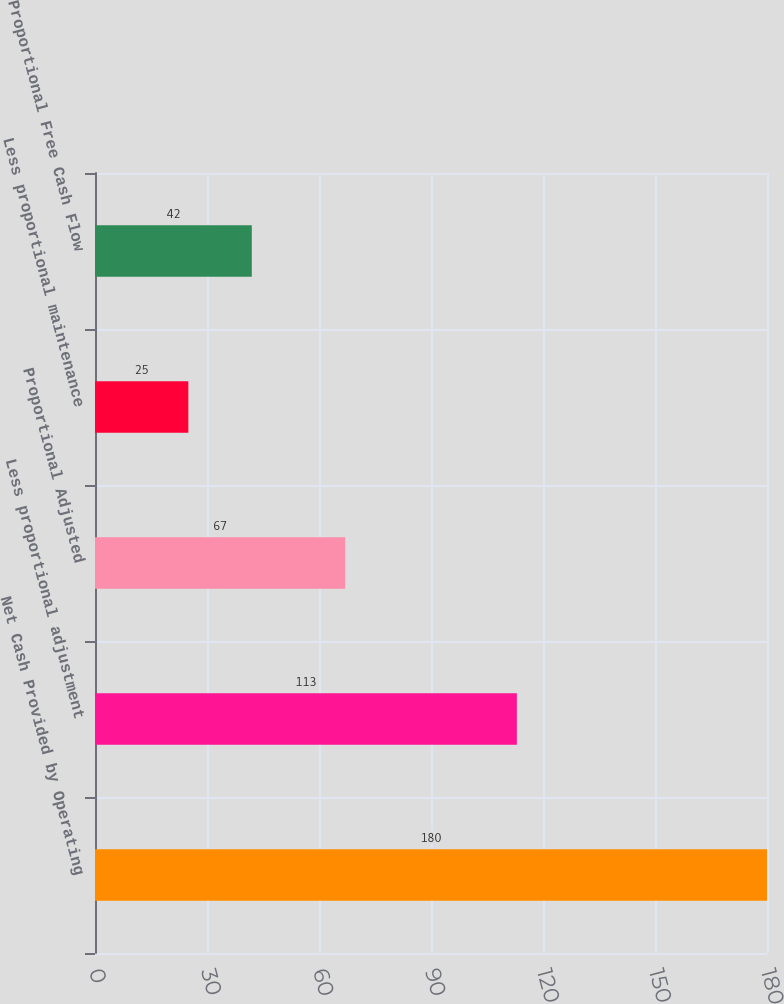Convert chart to OTSL. <chart><loc_0><loc_0><loc_500><loc_500><bar_chart><fcel>Net Cash Provided by Operating<fcel>Less proportional adjustment<fcel>Proportional Adjusted<fcel>Less proportional maintenance<fcel>Proportional Free Cash Flow<nl><fcel>180<fcel>113<fcel>67<fcel>25<fcel>42<nl></chart> 